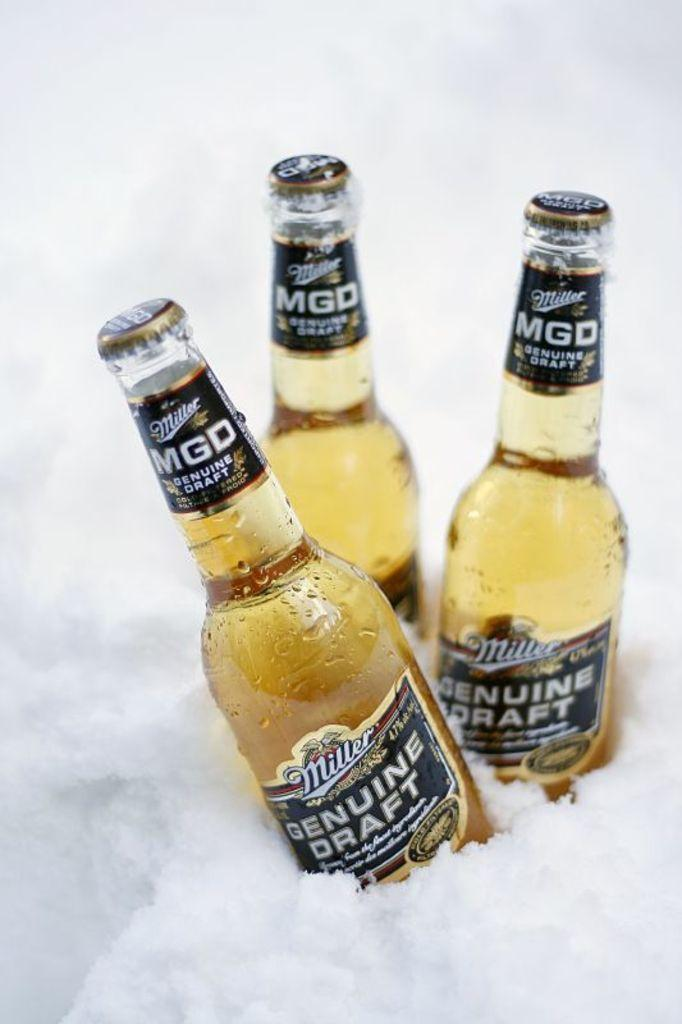<image>
Create a compact narrative representing the image presented. Three bottles of Miller Genuine Draft Beer are being chilled with ice. 